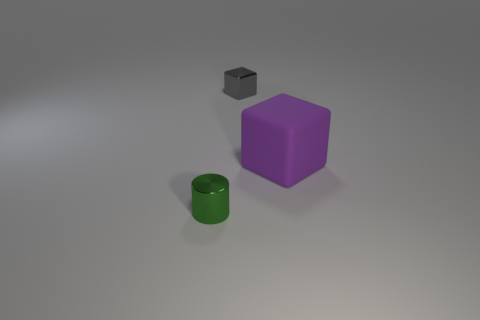How many other objects are there of the same material as the purple block? Upon examining the image, it appears that none of the other objects share the same matte plastic finish as the purple block. Therefore, the enhanced answer is that there are zero objects made of the same material as the purple block. 